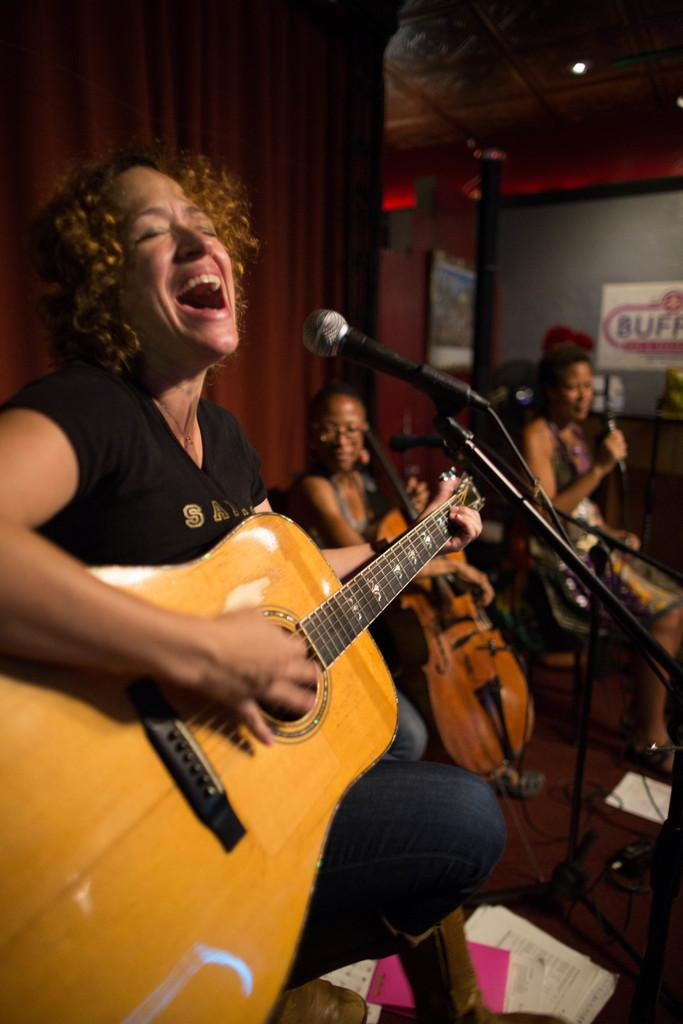What is the woman in the image doing? The woman is singing a song. What instrument is the woman holding in the image? The woman is holding a guitar. How many people are visible behind the woman? There are two people behind the woman. What can be seen on the left side in the background of the image? There is a curtain on the left side in the background of the image. What type of headwear is the woman wearing while singing the song? The image does not show the woman wearing any headwear. 